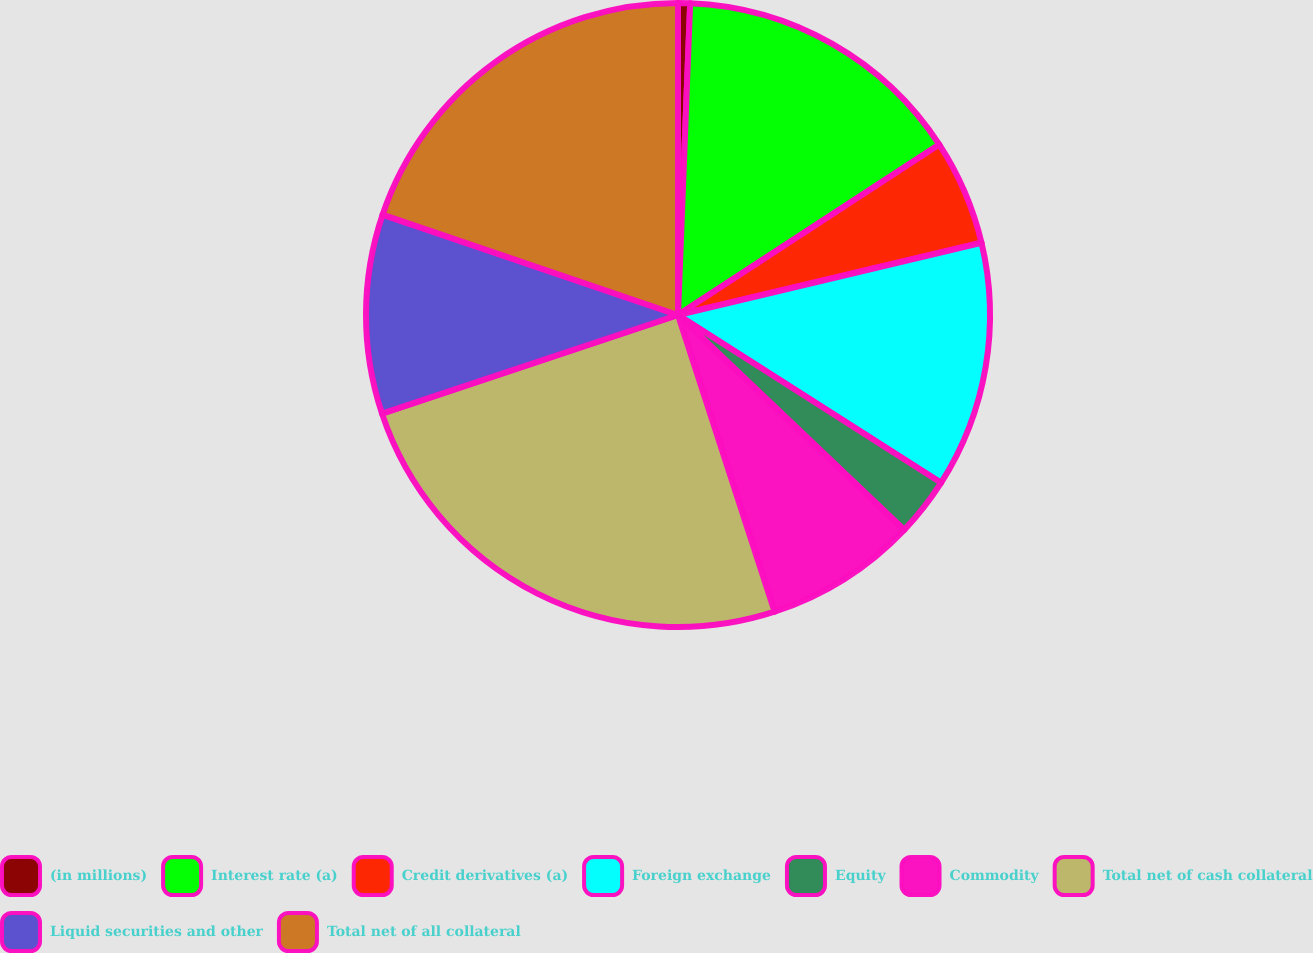Convert chart to OTSL. <chart><loc_0><loc_0><loc_500><loc_500><pie_chart><fcel>(in millions)<fcel>Interest rate (a)<fcel>Credit derivatives (a)<fcel>Foreign exchange<fcel>Equity<fcel>Commodity<fcel>Total net of cash collateral<fcel>Liquid securities and other<fcel>Total net of all collateral<nl><fcel>0.62%<fcel>15.18%<fcel>5.48%<fcel>12.76%<fcel>3.05%<fcel>7.9%<fcel>24.89%<fcel>10.33%<fcel>19.79%<nl></chart> 